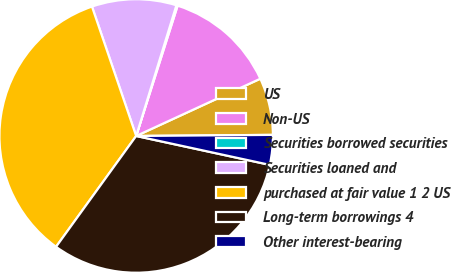Convert chart to OTSL. <chart><loc_0><loc_0><loc_500><loc_500><pie_chart><fcel>US<fcel>Non-US<fcel>Securities borrowed securities<fcel>Securities loaned and<fcel>purchased at fair value 1 2 US<fcel>Long-term borrowings 4<fcel>Other interest-bearing<nl><fcel>6.75%<fcel>13.22%<fcel>0.15%<fcel>9.99%<fcel>34.8%<fcel>31.57%<fcel>3.52%<nl></chart> 